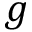<formula> <loc_0><loc_0><loc_500><loc_500>g</formula> 